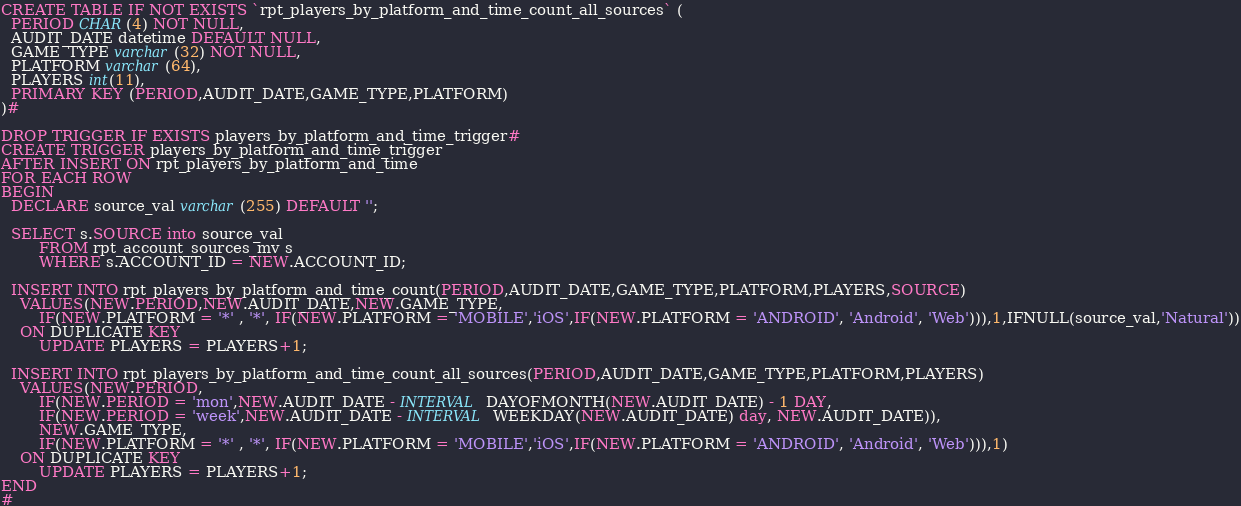Convert code to text. <code><loc_0><loc_0><loc_500><loc_500><_SQL_>CREATE TABLE IF NOT EXISTS `rpt_players_by_platform_and_time_count_all_sources` (
  PERIOD CHAR(4) NOT NULL,
  AUDIT_DATE datetime DEFAULT NULL,
  GAME_TYPE varchar(32) NOT NULL,
  PLATFORM varchar(64),
  PLAYERS int(11),
  PRIMARY KEY (PERIOD,AUDIT_DATE,GAME_TYPE,PLATFORM)
)#

DROP TRIGGER IF EXISTS players_by_platform_and_time_trigger#
CREATE TRIGGER players_by_platform_and_time_trigger
AFTER INSERT ON rpt_players_by_platform_and_time
FOR EACH ROW
BEGIN
  DECLARE source_val varchar(255) DEFAULT '';
  
  SELECT s.SOURCE into source_val
		FROM rpt_account_sources_mv s
		WHERE s.ACCOUNT_ID = NEW.ACCOUNT_ID;

  INSERT INTO rpt_players_by_platform_and_time_count(PERIOD,AUDIT_DATE,GAME_TYPE,PLATFORM,PLAYERS,SOURCE)
  	VALUES(NEW.PERIOD,NEW.AUDIT_DATE,NEW.GAME_TYPE,
  		IF(NEW.PLATFORM = '*' , '*', IF(NEW.PLATFORM = 'MOBILE','iOS',IF(NEW.PLATFORM = 'ANDROID', 'Android', 'Web'))),1,IFNULL(source_val,'Natural'))
  	ON DUPLICATE KEY
	  	UPDATE PLAYERS = PLAYERS+1;
	  	
  INSERT INTO rpt_players_by_platform_and_time_count_all_sources(PERIOD,AUDIT_DATE,GAME_TYPE,PLATFORM,PLAYERS)
  	VALUES(NEW.PERIOD,
  		IF(NEW.PERIOD = 'mon',NEW.AUDIT_DATE - INTERVAL DAYOFMONTH(NEW.AUDIT_DATE) - 1 DAY,
		IF(NEW.PERIOD = 'week',NEW.AUDIT_DATE - INTERVAL WEEKDAY(NEW.AUDIT_DATE) day, NEW.AUDIT_DATE)),
  		NEW.GAME_TYPE,
  		IF(NEW.PLATFORM = '*' , '*', IF(NEW.PLATFORM = 'MOBILE','iOS',IF(NEW.PLATFORM = 'ANDROID', 'Android', 'Web'))),1)
  	ON DUPLICATE KEY
	  	UPDATE PLAYERS = PLAYERS+1;
END
#</code> 